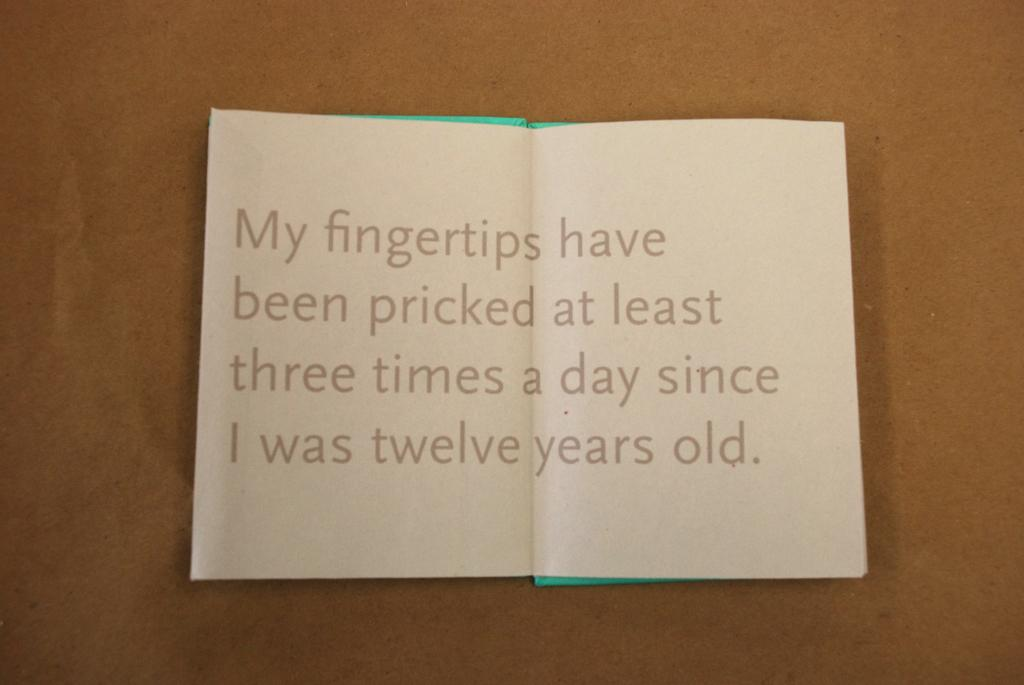<image>
Create a compact narrative representing the image presented. A page from a book that has the words My fingertips have been pricked at least three times a day since I was twelve years old. 